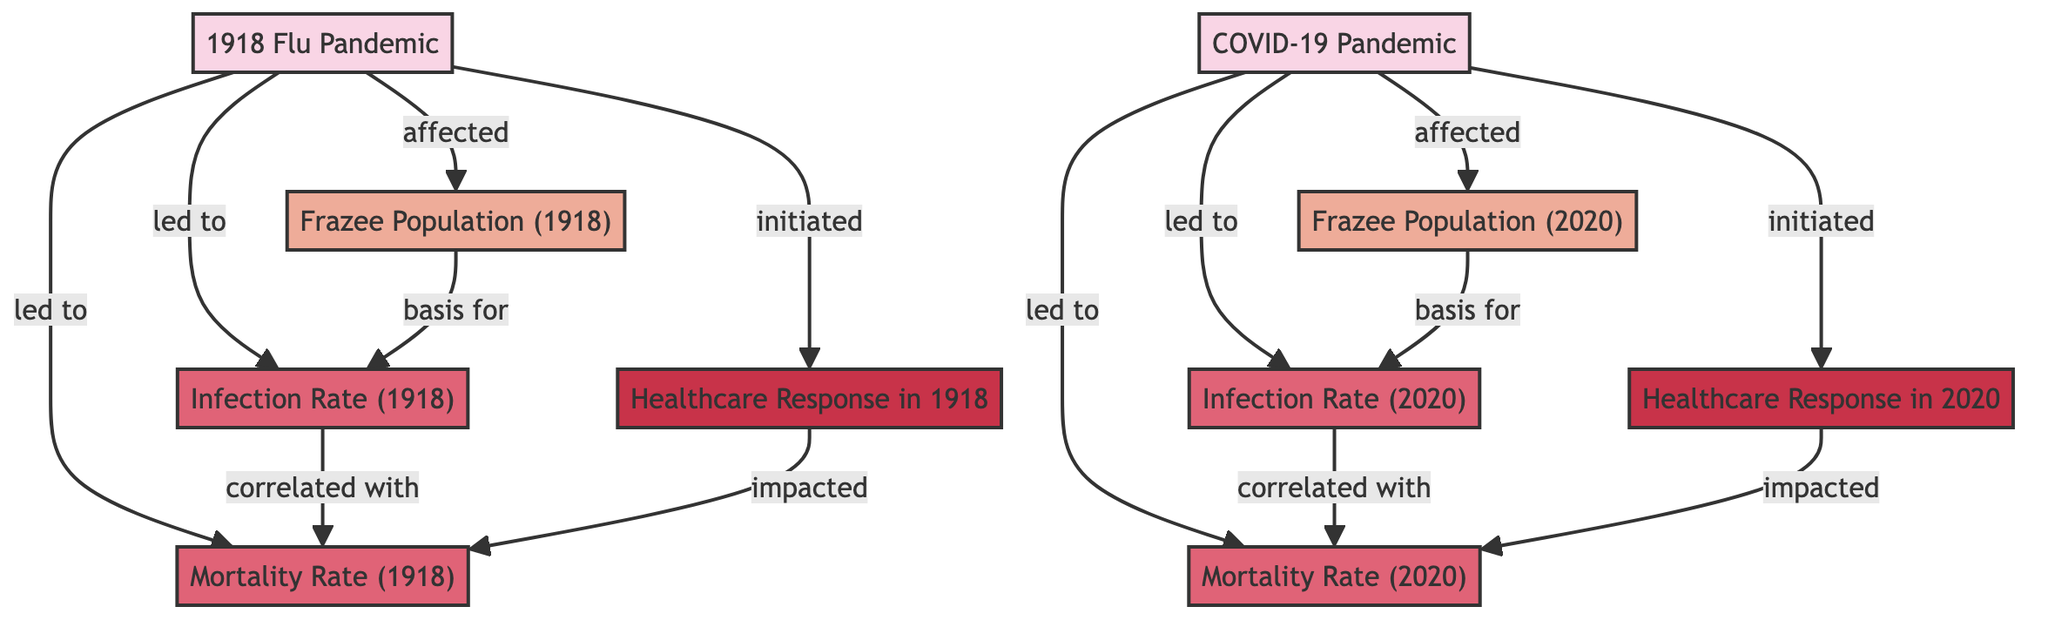What event affected the population of Frazee in 1918? The diagram shows that the "1918 Flu Pandemic" is the event that directly affected the population of Frazee in that year.
Answer: 1918 Flu Pandemic What was the population of Frazee in 2020? According to the diagram, the node for "Frazee Population (2020)" represents the specific data point being asked, which is stated directly in that node.
Answer: Frazee Population (2020) How did the healthcare response in 2020 impact the mortality rate? The diagram indicates a connection between "Healthcare Response in 2020" and "Mortality Rate (2020)," showing that the response influenced the mortality rate during the COVID-19 pandemic.
Answer: Impacted What is the infection rate for the 1918 flu pandemic? In the diagram, the node labeled "Infection Rate (1918)" indicates the statistical data related to the infection rate during that time period.
Answer: Infection Rate (1918) Which pandemic led to a higher mortality rate? The diagram correlates the "Mortality Rate (1918)" and "Mortality Rate (2020)" with their respective events, and since the historical pandemic typically had a higher mortality rate, interpreting the connections in the diagram leads to this understanding.
Answer: 1918 Flu Pandemic What was initiated by the 1918 flu pandemic? From the diagram, it's clear that the "1918 Flu Pandemic" initiated healthcare response in 1918, as depicted by the direct connection shown in the flow.
Answer: Healthcare Response in 1918 What is the correlation between infection rates and mortality rates? The diagram displays that "Infection Rate (1918)" is correlated with "Mortality Rate (1918)," and similarly for the COVID-19 rates, indicating that these rates are related and affect each other.
Answer: Correlated What led to the infection rate in Frazee during COVID-19? According to the diagram, the "Frazee Population (2020)" serves as the basis for determining the "Infection Rate (2020)," which indicates that the population data was critical in assessing infection rates.
Answer: Basis for What is the class color associated with population data? By observing the diagram's class definitions, the color specifically assigned to nodes labeled as "population_data" is identified, which is a light orange shade.
Answer: Light orange 